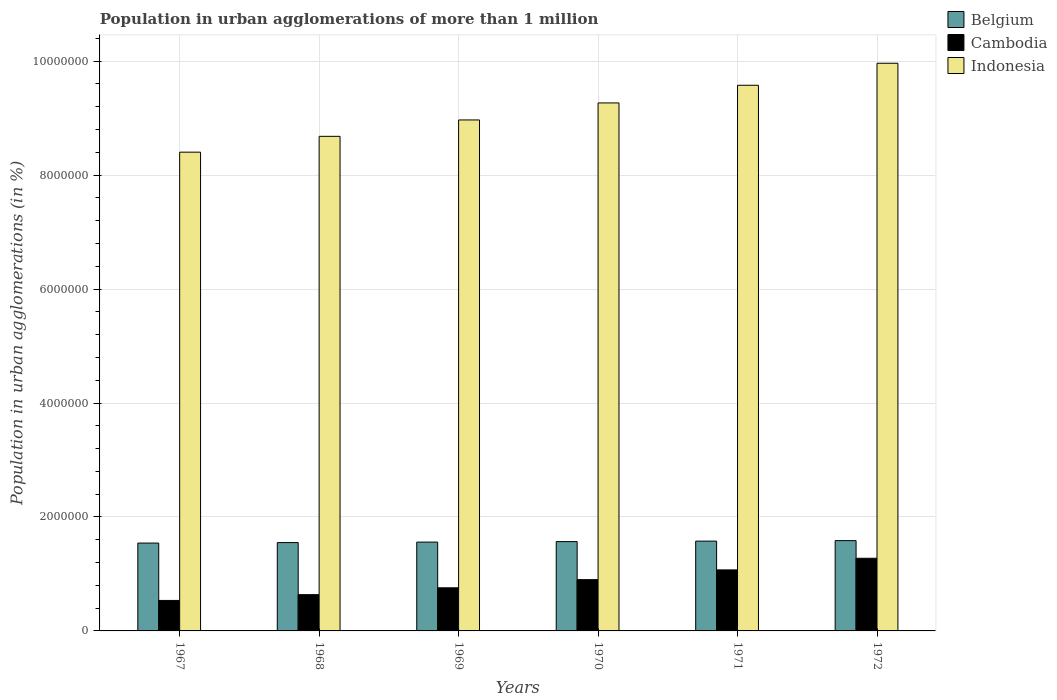How many different coloured bars are there?
Your answer should be very brief. 3. Are the number of bars per tick equal to the number of legend labels?
Provide a short and direct response. Yes. Are the number of bars on each tick of the X-axis equal?
Your response must be concise. Yes. What is the label of the 2nd group of bars from the left?
Make the answer very short. 1968. What is the population in urban agglomerations in Belgium in 1972?
Provide a short and direct response. 1.58e+06. Across all years, what is the maximum population in urban agglomerations in Belgium?
Your answer should be very brief. 1.58e+06. Across all years, what is the minimum population in urban agglomerations in Belgium?
Your answer should be compact. 1.54e+06. In which year was the population in urban agglomerations in Cambodia maximum?
Your response must be concise. 1972. In which year was the population in urban agglomerations in Cambodia minimum?
Your response must be concise. 1967. What is the total population in urban agglomerations in Cambodia in the graph?
Provide a succinct answer. 5.17e+06. What is the difference between the population in urban agglomerations in Belgium in 1967 and that in 1969?
Keep it short and to the point. -1.72e+04. What is the difference between the population in urban agglomerations in Belgium in 1969 and the population in urban agglomerations in Cambodia in 1972?
Offer a very short reply. 2.84e+05. What is the average population in urban agglomerations in Indonesia per year?
Offer a very short reply. 9.14e+06. In the year 1969, what is the difference between the population in urban agglomerations in Cambodia and population in urban agglomerations in Indonesia?
Make the answer very short. -8.21e+06. What is the ratio of the population in urban agglomerations in Indonesia in 1970 to that in 1971?
Offer a very short reply. 0.97. What is the difference between the highest and the second highest population in urban agglomerations in Cambodia?
Give a very brief answer. 2.04e+05. What is the difference between the highest and the lowest population in urban agglomerations in Cambodia?
Your answer should be compact. 7.40e+05. In how many years, is the population in urban agglomerations in Cambodia greater than the average population in urban agglomerations in Cambodia taken over all years?
Provide a succinct answer. 3. Is the sum of the population in urban agglomerations in Belgium in 1968 and 1969 greater than the maximum population in urban agglomerations in Indonesia across all years?
Give a very brief answer. No. What does the 2nd bar from the left in 1969 represents?
Make the answer very short. Cambodia. What does the 2nd bar from the right in 1968 represents?
Provide a succinct answer. Cambodia. What is the difference between two consecutive major ticks on the Y-axis?
Make the answer very short. 2.00e+06. Are the values on the major ticks of Y-axis written in scientific E-notation?
Provide a succinct answer. No. Does the graph contain any zero values?
Keep it short and to the point. No. Does the graph contain grids?
Provide a short and direct response. Yes. Where does the legend appear in the graph?
Your answer should be compact. Top right. How many legend labels are there?
Your answer should be very brief. 3. How are the legend labels stacked?
Provide a succinct answer. Vertical. What is the title of the graph?
Give a very brief answer. Population in urban agglomerations of more than 1 million. Does "Andorra" appear as one of the legend labels in the graph?
Provide a succinct answer. No. What is the label or title of the X-axis?
Make the answer very short. Years. What is the label or title of the Y-axis?
Keep it short and to the point. Population in urban agglomerations (in %). What is the Population in urban agglomerations (in %) in Belgium in 1967?
Provide a short and direct response. 1.54e+06. What is the Population in urban agglomerations (in %) of Cambodia in 1967?
Offer a terse response. 5.35e+05. What is the Population in urban agglomerations (in %) in Indonesia in 1967?
Your answer should be compact. 8.40e+06. What is the Population in urban agglomerations (in %) of Belgium in 1968?
Provide a short and direct response. 1.55e+06. What is the Population in urban agglomerations (in %) in Cambodia in 1968?
Provide a succinct answer. 6.37e+05. What is the Population in urban agglomerations (in %) of Indonesia in 1968?
Your answer should be compact. 8.68e+06. What is the Population in urban agglomerations (in %) in Belgium in 1969?
Your answer should be compact. 1.56e+06. What is the Population in urban agglomerations (in %) in Cambodia in 1969?
Keep it short and to the point. 7.57e+05. What is the Population in urban agglomerations (in %) in Indonesia in 1969?
Offer a very short reply. 8.97e+06. What is the Population in urban agglomerations (in %) of Belgium in 1970?
Offer a very short reply. 1.57e+06. What is the Population in urban agglomerations (in %) in Indonesia in 1970?
Offer a very short reply. 9.27e+06. What is the Population in urban agglomerations (in %) of Belgium in 1971?
Offer a very short reply. 1.58e+06. What is the Population in urban agglomerations (in %) in Cambodia in 1971?
Your answer should be very brief. 1.07e+06. What is the Population in urban agglomerations (in %) of Indonesia in 1971?
Your answer should be compact. 9.58e+06. What is the Population in urban agglomerations (in %) in Belgium in 1972?
Your answer should be very brief. 1.58e+06. What is the Population in urban agglomerations (in %) of Cambodia in 1972?
Ensure brevity in your answer.  1.27e+06. What is the Population in urban agglomerations (in %) of Indonesia in 1972?
Your answer should be very brief. 9.96e+06. Across all years, what is the maximum Population in urban agglomerations (in %) of Belgium?
Make the answer very short. 1.58e+06. Across all years, what is the maximum Population in urban agglomerations (in %) of Cambodia?
Provide a short and direct response. 1.27e+06. Across all years, what is the maximum Population in urban agglomerations (in %) of Indonesia?
Make the answer very short. 9.96e+06. Across all years, what is the minimum Population in urban agglomerations (in %) of Belgium?
Your answer should be compact. 1.54e+06. Across all years, what is the minimum Population in urban agglomerations (in %) of Cambodia?
Your answer should be very brief. 5.35e+05. Across all years, what is the minimum Population in urban agglomerations (in %) in Indonesia?
Make the answer very short. 8.40e+06. What is the total Population in urban agglomerations (in %) of Belgium in the graph?
Make the answer very short. 9.38e+06. What is the total Population in urban agglomerations (in %) in Cambodia in the graph?
Provide a short and direct response. 5.17e+06. What is the total Population in urban agglomerations (in %) of Indonesia in the graph?
Your response must be concise. 5.49e+07. What is the difference between the Population in urban agglomerations (in %) in Belgium in 1967 and that in 1968?
Provide a succinct answer. -8585. What is the difference between the Population in urban agglomerations (in %) of Cambodia in 1967 and that in 1968?
Your answer should be very brief. -1.01e+05. What is the difference between the Population in urban agglomerations (in %) of Indonesia in 1967 and that in 1968?
Provide a succinct answer. -2.78e+05. What is the difference between the Population in urban agglomerations (in %) in Belgium in 1967 and that in 1969?
Keep it short and to the point. -1.72e+04. What is the difference between the Population in urban agglomerations (in %) of Cambodia in 1967 and that in 1969?
Provide a short and direct response. -2.22e+05. What is the difference between the Population in urban agglomerations (in %) of Indonesia in 1967 and that in 1969?
Your answer should be compact. -5.65e+05. What is the difference between the Population in urban agglomerations (in %) in Belgium in 1967 and that in 1970?
Ensure brevity in your answer.  -2.59e+04. What is the difference between the Population in urban agglomerations (in %) of Cambodia in 1967 and that in 1970?
Give a very brief answer. -3.65e+05. What is the difference between the Population in urban agglomerations (in %) of Indonesia in 1967 and that in 1970?
Offer a very short reply. -8.64e+05. What is the difference between the Population in urban agglomerations (in %) of Belgium in 1967 and that in 1971?
Your answer should be compact. -3.44e+04. What is the difference between the Population in urban agglomerations (in %) of Cambodia in 1967 and that in 1971?
Your answer should be compact. -5.36e+05. What is the difference between the Population in urban agglomerations (in %) of Indonesia in 1967 and that in 1971?
Keep it short and to the point. -1.17e+06. What is the difference between the Population in urban agglomerations (in %) in Belgium in 1967 and that in 1972?
Make the answer very short. -4.29e+04. What is the difference between the Population in urban agglomerations (in %) of Cambodia in 1967 and that in 1972?
Make the answer very short. -7.40e+05. What is the difference between the Population in urban agglomerations (in %) of Indonesia in 1967 and that in 1972?
Offer a terse response. -1.56e+06. What is the difference between the Population in urban agglomerations (in %) in Belgium in 1968 and that in 1969?
Give a very brief answer. -8609. What is the difference between the Population in urban agglomerations (in %) in Cambodia in 1968 and that in 1969?
Ensure brevity in your answer.  -1.20e+05. What is the difference between the Population in urban agglomerations (in %) in Indonesia in 1968 and that in 1969?
Keep it short and to the point. -2.88e+05. What is the difference between the Population in urban agglomerations (in %) in Belgium in 1968 and that in 1970?
Provide a succinct answer. -1.73e+04. What is the difference between the Population in urban agglomerations (in %) in Cambodia in 1968 and that in 1970?
Offer a terse response. -2.63e+05. What is the difference between the Population in urban agglomerations (in %) of Indonesia in 1968 and that in 1970?
Your answer should be compact. -5.86e+05. What is the difference between the Population in urban agglomerations (in %) of Belgium in 1968 and that in 1971?
Provide a succinct answer. -2.58e+04. What is the difference between the Population in urban agglomerations (in %) of Cambodia in 1968 and that in 1971?
Provide a succinct answer. -4.35e+05. What is the difference between the Population in urban agglomerations (in %) in Indonesia in 1968 and that in 1971?
Make the answer very short. -8.96e+05. What is the difference between the Population in urban agglomerations (in %) in Belgium in 1968 and that in 1972?
Provide a short and direct response. -3.43e+04. What is the difference between the Population in urban agglomerations (in %) of Cambodia in 1968 and that in 1972?
Your answer should be very brief. -6.38e+05. What is the difference between the Population in urban agglomerations (in %) in Indonesia in 1968 and that in 1972?
Offer a terse response. -1.28e+06. What is the difference between the Population in urban agglomerations (in %) in Belgium in 1969 and that in 1970?
Your answer should be very brief. -8669. What is the difference between the Population in urban agglomerations (in %) of Cambodia in 1969 and that in 1970?
Offer a very short reply. -1.43e+05. What is the difference between the Population in urban agglomerations (in %) in Indonesia in 1969 and that in 1970?
Your answer should be very brief. -2.99e+05. What is the difference between the Population in urban agglomerations (in %) in Belgium in 1969 and that in 1971?
Your response must be concise. -1.72e+04. What is the difference between the Population in urban agglomerations (in %) of Cambodia in 1969 and that in 1971?
Offer a very short reply. -3.14e+05. What is the difference between the Population in urban agglomerations (in %) in Indonesia in 1969 and that in 1971?
Keep it short and to the point. -6.09e+05. What is the difference between the Population in urban agglomerations (in %) in Belgium in 1969 and that in 1972?
Keep it short and to the point. -2.57e+04. What is the difference between the Population in urban agglomerations (in %) in Cambodia in 1969 and that in 1972?
Provide a succinct answer. -5.18e+05. What is the difference between the Population in urban agglomerations (in %) in Indonesia in 1969 and that in 1972?
Give a very brief answer. -9.95e+05. What is the difference between the Population in urban agglomerations (in %) of Belgium in 1970 and that in 1971?
Provide a succinct answer. -8555. What is the difference between the Population in urban agglomerations (in %) in Cambodia in 1970 and that in 1971?
Keep it short and to the point. -1.71e+05. What is the difference between the Population in urban agglomerations (in %) of Indonesia in 1970 and that in 1971?
Provide a short and direct response. -3.10e+05. What is the difference between the Population in urban agglomerations (in %) of Belgium in 1970 and that in 1972?
Ensure brevity in your answer.  -1.70e+04. What is the difference between the Population in urban agglomerations (in %) in Cambodia in 1970 and that in 1972?
Your response must be concise. -3.75e+05. What is the difference between the Population in urban agglomerations (in %) of Indonesia in 1970 and that in 1972?
Make the answer very short. -6.96e+05. What is the difference between the Population in urban agglomerations (in %) in Belgium in 1971 and that in 1972?
Make the answer very short. -8449. What is the difference between the Population in urban agglomerations (in %) in Cambodia in 1971 and that in 1972?
Offer a very short reply. -2.04e+05. What is the difference between the Population in urban agglomerations (in %) in Indonesia in 1971 and that in 1972?
Provide a short and direct response. -3.86e+05. What is the difference between the Population in urban agglomerations (in %) of Belgium in 1967 and the Population in urban agglomerations (in %) of Cambodia in 1968?
Offer a very short reply. 9.05e+05. What is the difference between the Population in urban agglomerations (in %) in Belgium in 1967 and the Population in urban agglomerations (in %) in Indonesia in 1968?
Your answer should be very brief. -7.14e+06. What is the difference between the Population in urban agglomerations (in %) of Cambodia in 1967 and the Population in urban agglomerations (in %) of Indonesia in 1968?
Offer a terse response. -8.15e+06. What is the difference between the Population in urban agglomerations (in %) of Belgium in 1967 and the Population in urban agglomerations (in %) of Cambodia in 1969?
Provide a short and direct response. 7.85e+05. What is the difference between the Population in urban agglomerations (in %) in Belgium in 1967 and the Population in urban agglomerations (in %) in Indonesia in 1969?
Keep it short and to the point. -7.43e+06. What is the difference between the Population in urban agglomerations (in %) in Cambodia in 1967 and the Population in urban agglomerations (in %) in Indonesia in 1969?
Ensure brevity in your answer.  -8.43e+06. What is the difference between the Population in urban agglomerations (in %) in Belgium in 1967 and the Population in urban agglomerations (in %) in Cambodia in 1970?
Provide a short and direct response. 6.42e+05. What is the difference between the Population in urban agglomerations (in %) in Belgium in 1967 and the Population in urban agglomerations (in %) in Indonesia in 1970?
Give a very brief answer. -7.73e+06. What is the difference between the Population in urban agglomerations (in %) of Cambodia in 1967 and the Population in urban agglomerations (in %) of Indonesia in 1970?
Give a very brief answer. -8.73e+06. What is the difference between the Population in urban agglomerations (in %) in Belgium in 1967 and the Population in urban agglomerations (in %) in Cambodia in 1971?
Make the answer very short. 4.71e+05. What is the difference between the Population in urban agglomerations (in %) in Belgium in 1967 and the Population in urban agglomerations (in %) in Indonesia in 1971?
Your response must be concise. -8.04e+06. What is the difference between the Population in urban agglomerations (in %) of Cambodia in 1967 and the Population in urban agglomerations (in %) of Indonesia in 1971?
Ensure brevity in your answer.  -9.04e+06. What is the difference between the Population in urban agglomerations (in %) of Belgium in 1967 and the Population in urban agglomerations (in %) of Cambodia in 1972?
Your answer should be compact. 2.67e+05. What is the difference between the Population in urban agglomerations (in %) of Belgium in 1967 and the Population in urban agglomerations (in %) of Indonesia in 1972?
Offer a terse response. -8.42e+06. What is the difference between the Population in urban agglomerations (in %) of Cambodia in 1967 and the Population in urban agglomerations (in %) of Indonesia in 1972?
Provide a succinct answer. -9.43e+06. What is the difference between the Population in urban agglomerations (in %) in Belgium in 1968 and the Population in urban agglomerations (in %) in Cambodia in 1969?
Make the answer very short. 7.94e+05. What is the difference between the Population in urban agglomerations (in %) in Belgium in 1968 and the Population in urban agglomerations (in %) in Indonesia in 1969?
Your answer should be very brief. -7.42e+06. What is the difference between the Population in urban agglomerations (in %) of Cambodia in 1968 and the Population in urban agglomerations (in %) of Indonesia in 1969?
Keep it short and to the point. -8.33e+06. What is the difference between the Population in urban agglomerations (in %) of Belgium in 1968 and the Population in urban agglomerations (in %) of Cambodia in 1970?
Keep it short and to the point. 6.50e+05. What is the difference between the Population in urban agglomerations (in %) of Belgium in 1968 and the Population in urban agglomerations (in %) of Indonesia in 1970?
Your answer should be compact. -7.72e+06. What is the difference between the Population in urban agglomerations (in %) of Cambodia in 1968 and the Population in urban agglomerations (in %) of Indonesia in 1970?
Give a very brief answer. -8.63e+06. What is the difference between the Population in urban agglomerations (in %) of Belgium in 1968 and the Population in urban agglomerations (in %) of Cambodia in 1971?
Your response must be concise. 4.79e+05. What is the difference between the Population in urban agglomerations (in %) of Belgium in 1968 and the Population in urban agglomerations (in %) of Indonesia in 1971?
Provide a succinct answer. -8.03e+06. What is the difference between the Population in urban agglomerations (in %) of Cambodia in 1968 and the Population in urban agglomerations (in %) of Indonesia in 1971?
Provide a succinct answer. -8.94e+06. What is the difference between the Population in urban agglomerations (in %) in Belgium in 1968 and the Population in urban agglomerations (in %) in Cambodia in 1972?
Provide a short and direct response. 2.75e+05. What is the difference between the Population in urban agglomerations (in %) of Belgium in 1968 and the Population in urban agglomerations (in %) of Indonesia in 1972?
Provide a short and direct response. -8.41e+06. What is the difference between the Population in urban agglomerations (in %) in Cambodia in 1968 and the Population in urban agglomerations (in %) in Indonesia in 1972?
Your answer should be very brief. -9.33e+06. What is the difference between the Population in urban agglomerations (in %) in Belgium in 1969 and the Population in urban agglomerations (in %) in Cambodia in 1970?
Offer a terse response. 6.59e+05. What is the difference between the Population in urban agglomerations (in %) in Belgium in 1969 and the Population in urban agglomerations (in %) in Indonesia in 1970?
Ensure brevity in your answer.  -7.71e+06. What is the difference between the Population in urban agglomerations (in %) of Cambodia in 1969 and the Population in urban agglomerations (in %) of Indonesia in 1970?
Provide a short and direct response. -8.51e+06. What is the difference between the Population in urban agglomerations (in %) of Belgium in 1969 and the Population in urban agglomerations (in %) of Cambodia in 1971?
Offer a very short reply. 4.88e+05. What is the difference between the Population in urban agglomerations (in %) in Belgium in 1969 and the Population in urban agglomerations (in %) in Indonesia in 1971?
Provide a succinct answer. -8.02e+06. What is the difference between the Population in urban agglomerations (in %) of Cambodia in 1969 and the Population in urban agglomerations (in %) of Indonesia in 1971?
Offer a very short reply. -8.82e+06. What is the difference between the Population in urban agglomerations (in %) of Belgium in 1969 and the Population in urban agglomerations (in %) of Cambodia in 1972?
Give a very brief answer. 2.84e+05. What is the difference between the Population in urban agglomerations (in %) of Belgium in 1969 and the Population in urban agglomerations (in %) of Indonesia in 1972?
Give a very brief answer. -8.40e+06. What is the difference between the Population in urban agglomerations (in %) in Cambodia in 1969 and the Population in urban agglomerations (in %) in Indonesia in 1972?
Offer a terse response. -9.21e+06. What is the difference between the Population in urban agglomerations (in %) in Belgium in 1970 and the Population in urban agglomerations (in %) in Cambodia in 1971?
Give a very brief answer. 4.97e+05. What is the difference between the Population in urban agglomerations (in %) in Belgium in 1970 and the Population in urban agglomerations (in %) in Indonesia in 1971?
Provide a short and direct response. -8.01e+06. What is the difference between the Population in urban agglomerations (in %) in Cambodia in 1970 and the Population in urban agglomerations (in %) in Indonesia in 1971?
Offer a very short reply. -8.68e+06. What is the difference between the Population in urban agglomerations (in %) in Belgium in 1970 and the Population in urban agglomerations (in %) in Cambodia in 1972?
Provide a short and direct response. 2.93e+05. What is the difference between the Population in urban agglomerations (in %) of Belgium in 1970 and the Population in urban agglomerations (in %) of Indonesia in 1972?
Provide a short and direct response. -8.40e+06. What is the difference between the Population in urban agglomerations (in %) in Cambodia in 1970 and the Population in urban agglomerations (in %) in Indonesia in 1972?
Your response must be concise. -9.06e+06. What is the difference between the Population in urban agglomerations (in %) of Belgium in 1971 and the Population in urban agglomerations (in %) of Cambodia in 1972?
Provide a succinct answer. 3.01e+05. What is the difference between the Population in urban agglomerations (in %) of Belgium in 1971 and the Population in urban agglomerations (in %) of Indonesia in 1972?
Your answer should be compact. -8.39e+06. What is the difference between the Population in urban agglomerations (in %) of Cambodia in 1971 and the Population in urban agglomerations (in %) of Indonesia in 1972?
Your answer should be very brief. -8.89e+06. What is the average Population in urban agglomerations (in %) in Belgium per year?
Your answer should be compact. 1.56e+06. What is the average Population in urban agglomerations (in %) in Cambodia per year?
Provide a short and direct response. 8.62e+05. What is the average Population in urban agglomerations (in %) of Indonesia per year?
Make the answer very short. 9.14e+06. In the year 1967, what is the difference between the Population in urban agglomerations (in %) of Belgium and Population in urban agglomerations (in %) of Cambodia?
Your answer should be compact. 1.01e+06. In the year 1967, what is the difference between the Population in urban agglomerations (in %) in Belgium and Population in urban agglomerations (in %) in Indonesia?
Ensure brevity in your answer.  -6.86e+06. In the year 1967, what is the difference between the Population in urban agglomerations (in %) in Cambodia and Population in urban agglomerations (in %) in Indonesia?
Offer a very short reply. -7.87e+06. In the year 1968, what is the difference between the Population in urban agglomerations (in %) in Belgium and Population in urban agglomerations (in %) in Cambodia?
Provide a short and direct response. 9.14e+05. In the year 1968, what is the difference between the Population in urban agglomerations (in %) in Belgium and Population in urban agglomerations (in %) in Indonesia?
Provide a short and direct response. -7.13e+06. In the year 1968, what is the difference between the Population in urban agglomerations (in %) in Cambodia and Population in urban agglomerations (in %) in Indonesia?
Provide a succinct answer. -8.04e+06. In the year 1969, what is the difference between the Population in urban agglomerations (in %) of Belgium and Population in urban agglomerations (in %) of Cambodia?
Provide a succinct answer. 8.02e+05. In the year 1969, what is the difference between the Population in urban agglomerations (in %) of Belgium and Population in urban agglomerations (in %) of Indonesia?
Your answer should be very brief. -7.41e+06. In the year 1969, what is the difference between the Population in urban agglomerations (in %) in Cambodia and Population in urban agglomerations (in %) in Indonesia?
Your answer should be compact. -8.21e+06. In the year 1970, what is the difference between the Population in urban agglomerations (in %) in Belgium and Population in urban agglomerations (in %) in Cambodia?
Make the answer very short. 6.68e+05. In the year 1970, what is the difference between the Population in urban agglomerations (in %) in Belgium and Population in urban agglomerations (in %) in Indonesia?
Your answer should be very brief. -7.70e+06. In the year 1970, what is the difference between the Population in urban agglomerations (in %) of Cambodia and Population in urban agglomerations (in %) of Indonesia?
Offer a terse response. -8.37e+06. In the year 1971, what is the difference between the Population in urban agglomerations (in %) in Belgium and Population in urban agglomerations (in %) in Cambodia?
Offer a terse response. 5.05e+05. In the year 1971, what is the difference between the Population in urban agglomerations (in %) of Belgium and Population in urban agglomerations (in %) of Indonesia?
Give a very brief answer. -8.00e+06. In the year 1971, what is the difference between the Population in urban agglomerations (in %) of Cambodia and Population in urban agglomerations (in %) of Indonesia?
Offer a very short reply. -8.51e+06. In the year 1972, what is the difference between the Population in urban agglomerations (in %) in Belgium and Population in urban agglomerations (in %) in Cambodia?
Your response must be concise. 3.10e+05. In the year 1972, what is the difference between the Population in urban agglomerations (in %) of Belgium and Population in urban agglomerations (in %) of Indonesia?
Make the answer very short. -8.38e+06. In the year 1972, what is the difference between the Population in urban agglomerations (in %) in Cambodia and Population in urban agglomerations (in %) in Indonesia?
Offer a very short reply. -8.69e+06. What is the ratio of the Population in urban agglomerations (in %) in Belgium in 1967 to that in 1968?
Give a very brief answer. 0.99. What is the ratio of the Population in urban agglomerations (in %) of Cambodia in 1967 to that in 1968?
Your response must be concise. 0.84. What is the ratio of the Population in urban agglomerations (in %) in Belgium in 1967 to that in 1969?
Provide a succinct answer. 0.99. What is the ratio of the Population in urban agglomerations (in %) in Cambodia in 1967 to that in 1969?
Your response must be concise. 0.71. What is the ratio of the Population in urban agglomerations (in %) of Indonesia in 1967 to that in 1969?
Your response must be concise. 0.94. What is the ratio of the Population in urban agglomerations (in %) of Belgium in 1967 to that in 1970?
Offer a very short reply. 0.98. What is the ratio of the Population in urban agglomerations (in %) of Cambodia in 1967 to that in 1970?
Provide a short and direct response. 0.59. What is the ratio of the Population in urban agglomerations (in %) in Indonesia in 1967 to that in 1970?
Your response must be concise. 0.91. What is the ratio of the Population in urban agglomerations (in %) of Belgium in 1967 to that in 1971?
Give a very brief answer. 0.98. What is the ratio of the Population in urban agglomerations (in %) in Cambodia in 1967 to that in 1971?
Your response must be concise. 0.5. What is the ratio of the Population in urban agglomerations (in %) in Indonesia in 1967 to that in 1971?
Your answer should be compact. 0.88. What is the ratio of the Population in urban agglomerations (in %) of Belgium in 1967 to that in 1972?
Offer a terse response. 0.97. What is the ratio of the Population in urban agglomerations (in %) in Cambodia in 1967 to that in 1972?
Provide a short and direct response. 0.42. What is the ratio of the Population in urban agglomerations (in %) in Indonesia in 1967 to that in 1972?
Keep it short and to the point. 0.84. What is the ratio of the Population in urban agglomerations (in %) in Cambodia in 1968 to that in 1969?
Offer a terse response. 0.84. What is the ratio of the Population in urban agglomerations (in %) in Indonesia in 1968 to that in 1969?
Provide a short and direct response. 0.97. What is the ratio of the Population in urban agglomerations (in %) in Belgium in 1968 to that in 1970?
Provide a short and direct response. 0.99. What is the ratio of the Population in urban agglomerations (in %) in Cambodia in 1968 to that in 1970?
Offer a very short reply. 0.71. What is the ratio of the Population in urban agglomerations (in %) of Indonesia in 1968 to that in 1970?
Offer a terse response. 0.94. What is the ratio of the Population in urban agglomerations (in %) in Belgium in 1968 to that in 1971?
Offer a very short reply. 0.98. What is the ratio of the Population in urban agglomerations (in %) in Cambodia in 1968 to that in 1971?
Your response must be concise. 0.59. What is the ratio of the Population in urban agglomerations (in %) of Indonesia in 1968 to that in 1971?
Provide a succinct answer. 0.91. What is the ratio of the Population in urban agglomerations (in %) of Belgium in 1968 to that in 1972?
Give a very brief answer. 0.98. What is the ratio of the Population in urban agglomerations (in %) of Cambodia in 1968 to that in 1972?
Provide a succinct answer. 0.5. What is the ratio of the Population in urban agglomerations (in %) in Indonesia in 1968 to that in 1972?
Make the answer very short. 0.87. What is the ratio of the Population in urban agglomerations (in %) in Belgium in 1969 to that in 1970?
Give a very brief answer. 0.99. What is the ratio of the Population in urban agglomerations (in %) of Cambodia in 1969 to that in 1970?
Provide a succinct answer. 0.84. What is the ratio of the Population in urban agglomerations (in %) of Indonesia in 1969 to that in 1970?
Provide a short and direct response. 0.97. What is the ratio of the Population in urban agglomerations (in %) in Cambodia in 1969 to that in 1971?
Ensure brevity in your answer.  0.71. What is the ratio of the Population in urban agglomerations (in %) in Indonesia in 1969 to that in 1971?
Give a very brief answer. 0.94. What is the ratio of the Population in urban agglomerations (in %) in Belgium in 1969 to that in 1972?
Make the answer very short. 0.98. What is the ratio of the Population in urban agglomerations (in %) of Cambodia in 1969 to that in 1972?
Offer a very short reply. 0.59. What is the ratio of the Population in urban agglomerations (in %) in Indonesia in 1969 to that in 1972?
Provide a short and direct response. 0.9. What is the ratio of the Population in urban agglomerations (in %) of Belgium in 1970 to that in 1971?
Make the answer very short. 0.99. What is the ratio of the Population in urban agglomerations (in %) of Cambodia in 1970 to that in 1971?
Your answer should be very brief. 0.84. What is the ratio of the Population in urban agglomerations (in %) of Indonesia in 1970 to that in 1971?
Your response must be concise. 0.97. What is the ratio of the Population in urban agglomerations (in %) of Belgium in 1970 to that in 1972?
Your answer should be very brief. 0.99. What is the ratio of the Population in urban agglomerations (in %) of Cambodia in 1970 to that in 1972?
Offer a terse response. 0.71. What is the ratio of the Population in urban agglomerations (in %) of Indonesia in 1970 to that in 1972?
Make the answer very short. 0.93. What is the ratio of the Population in urban agglomerations (in %) of Cambodia in 1971 to that in 1972?
Your answer should be very brief. 0.84. What is the ratio of the Population in urban agglomerations (in %) in Indonesia in 1971 to that in 1972?
Keep it short and to the point. 0.96. What is the difference between the highest and the second highest Population in urban agglomerations (in %) of Belgium?
Your answer should be very brief. 8449. What is the difference between the highest and the second highest Population in urban agglomerations (in %) in Cambodia?
Provide a short and direct response. 2.04e+05. What is the difference between the highest and the second highest Population in urban agglomerations (in %) in Indonesia?
Your response must be concise. 3.86e+05. What is the difference between the highest and the lowest Population in urban agglomerations (in %) in Belgium?
Keep it short and to the point. 4.29e+04. What is the difference between the highest and the lowest Population in urban agglomerations (in %) of Cambodia?
Ensure brevity in your answer.  7.40e+05. What is the difference between the highest and the lowest Population in urban agglomerations (in %) in Indonesia?
Keep it short and to the point. 1.56e+06. 